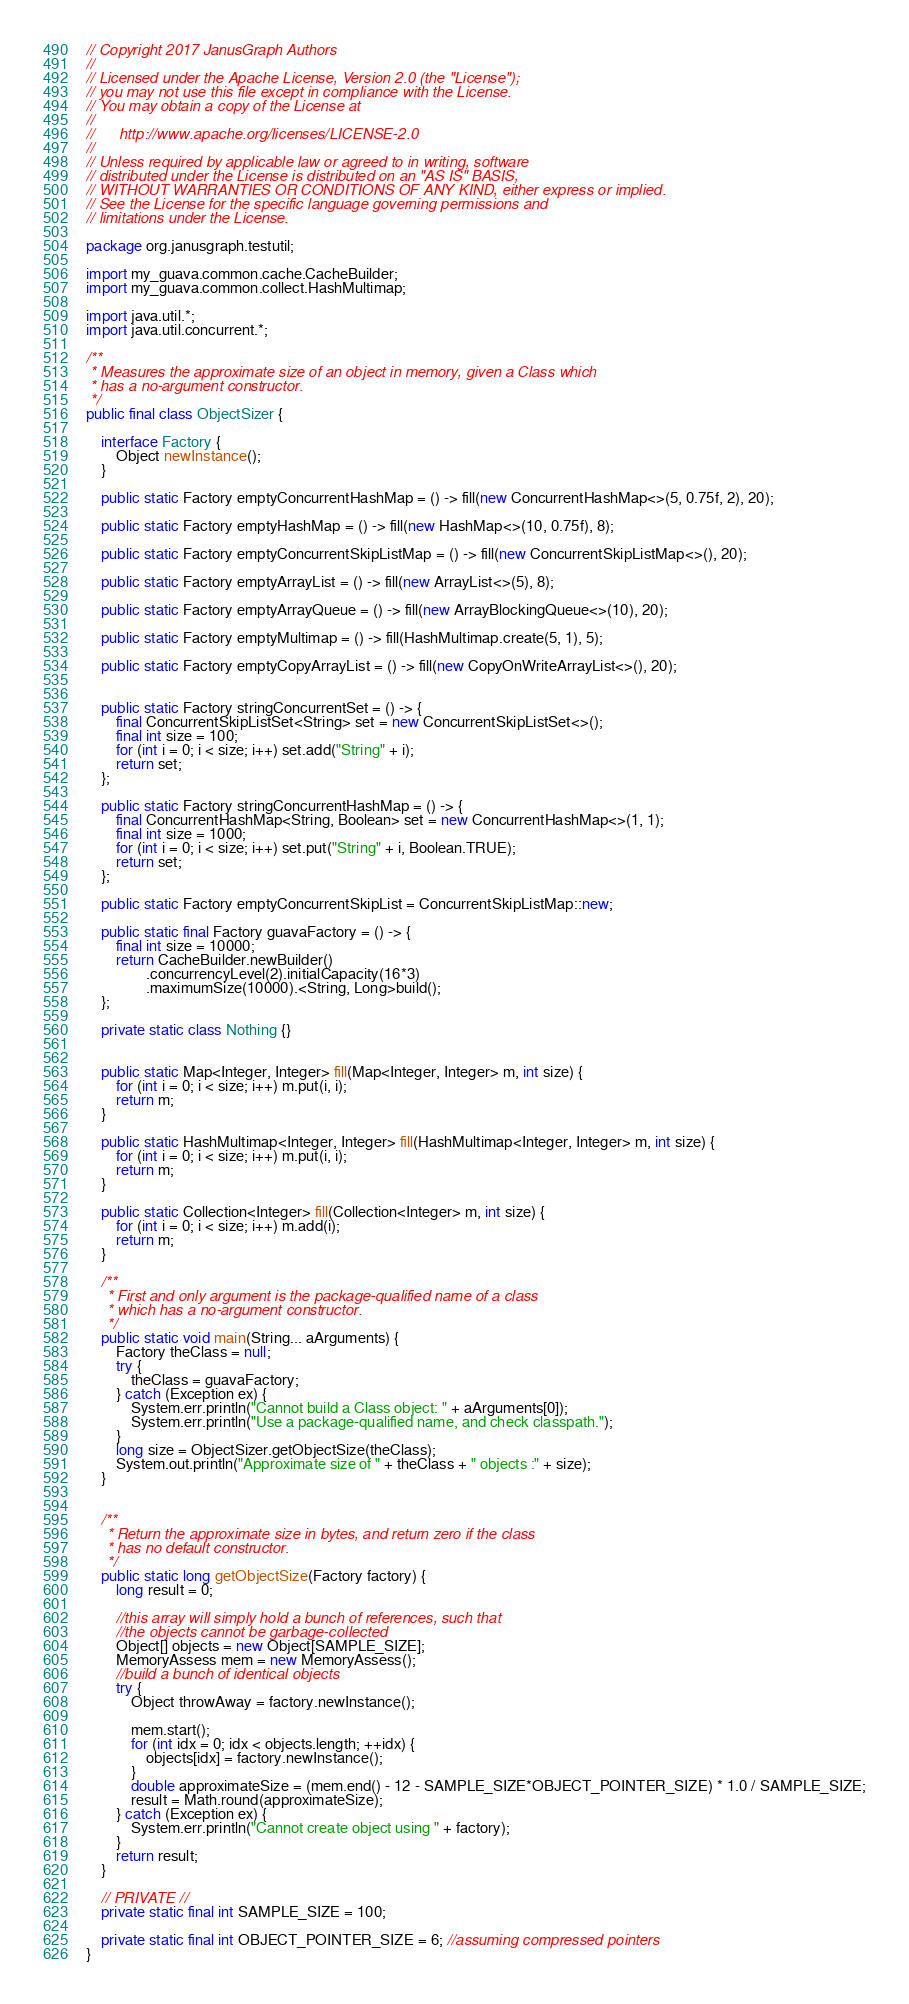Convert code to text. <code><loc_0><loc_0><loc_500><loc_500><_Java_>// Copyright 2017 JanusGraph Authors
//
// Licensed under the Apache License, Version 2.0 (the "License");
// you may not use this file except in compliance with the License.
// You may obtain a copy of the License at
//
//      http://www.apache.org/licenses/LICENSE-2.0
//
// Unless required by applicable law or agreed to in writing, software
// distributed under the License is distributed on an "AS IS" BASIS,
// WITHOUT WARRANTIES OR CONDITIONS OF ANY KIND, either express or implied.
// See the License for the specific language governing permissions and
// limitations under the License.

package org.janusgraph.testutil;

import my_guava.common.cache.CacheBuilder;
import my_guava.common.collect.HashMultimap;

import java.util.*;
import java.util.concurrent.*;

/**
 * Measures the approximate size of an object in memory, given a Class which
 * has a no-argument constructor.
 */
public final class ObjectSizer {

    interface Factory {
        Object newInstance();
    }

    public static Factory emptyConcurrentHashMap = () -> fill(new ConcurrentHashMap<>(5, 0.75f, 2), 20);

    public static Factory emptyHashMap = () -> fill(new HashMap<>(10, 0.75f), 8);

    public static Factory emptyConcurrentSkipListMap = () -> fill(new ConcurrentSkipListMap<>(), 20);

    public static Factory emptyArrayList = () -> fill(new ArrayList<>(5), 8);

    public static Factory emptyArrayQueue = () -> fill(new ArrayBlockingQueue<>(10), 20);

    public static Factory emptyMultimap = () -> fill(HashMultimap.create(5, 1), 5);

    public static Factory emptyCopyArrayList = () -> fill(new CopyOnWriteArrayList<>(), 20);


    public static Factory stringConcurrentSet = () -> {
        final ConcurrentSkipListSet<String> set = new ConcurrentSkipListSet<>();
        final int size = 100;
        for (int i = 0; i < size; i++) set.add("String" + i);
        return set;
    };

    public static Factory stringConcurrentHashMap = () -> {
        final ConcurrentHashMap<String, Boolean> set = new ConcurrentHashMap<>(1, 1);
        final int size = 1000;
        for (int i = 0; i < size; i++) set.put("String" + i, Boolean.TRUE);
        return set;
    };

    public static Factory emptyConcurrentSkipList = ConcurrentSkipListMap::new;

    public static final Factory guavaFactory = () -> {
        final int size = 10000;
        return CacheBuilder.newBuilder()
                .concurrencyLevel(2).initialCapacity(16*3)
                .maximumSize(10000).<String, Long>build();
    };

    private static class Nothing {}


    public static Map<Integer, Integer> fill(Map<Integer, Integer> m, int size) {
        for (int i = 0; i < size; i++) m.put(i, i);
        return m;
    }

    public static HashMultimap<Integer, Integer> fill(HashMultimap<Integer, Integer> m, int size) {
        for (int i = 0; i < size; i++) m.put(i, i);
        return m;
    }

    public static Collection<Integer> fill(Collection<Integer> m, int size) {
        for (int i = 0; i < size; i++) m.add(i);
        return m;
    }

    /**
     * First and only argument is the package-qualified name of a class
     * which has a no-argument constructor.
     */
    public static void main(String... aArguments) {
        Factory theClass = null;
        try {
            theClass = guavaFactory;
        } catch (Exception ex) {
            System.err.println("Cannot build a Class object: " + aArguments[0]);
            System.err.println("Use a package-qualified name, and check classpath.");
        }
        long size = ObjectSizer.getObjectSize(theClass);
        System.out.println("Approximate size of " + theClass + " objects :" + size);
    }


    /**
     * Return the approximate size in bytes, and return zero if the class
     * has no default constructor.
     */
    public static long getObjectSize(Factory factory) {
        long result = 0;

        //this array will simply hold a bunch of references, such that
        //the objects cannot be garbage-collected
        Object[] objects = new Object[SAMPLE_SIZE];
        MemoryAssess mem = new MemoryAssess();
        //build a bunch of identical objects
        try {
            Object throwAway = factory.newInstance();

            mem.start();
            for (int idx = 0; idx < objects.length; ++idx) {
                objects[idx] = factory.newInstance();
            }
            double approximateSize = (mem.end() - 12 - SAMPLE_SIZE*OBJECT_POINTER_SIZE) * 1.0 / SAMPLE_SIZE;
            result = Math.round(approximateSize);
        } catch (Exception ex) {
            System.err.println("Cannot create object using " + factory);
        }
        return result;
    }

    // PRIVATE //
    private static final int SAMPLE_SIZE = 100;

    private static final int OBJECT_POINTER_SIZE = 6; //assuming compressed pointers
}
</code> 